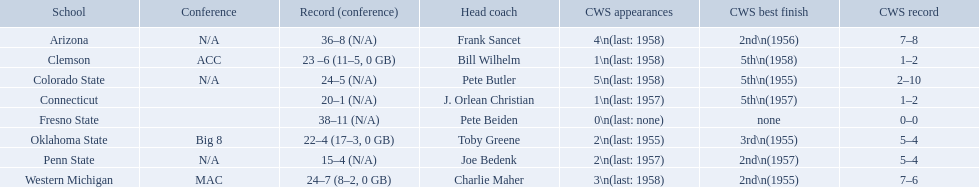Could you help me parse every detail presented in this table? {'header': ['School', 'Conference', 'Record (conference)', 'Head coach', 'CWS appearances', 'CWS best finish', 'CWS record'], 'rows': [['Arizona', 'N/A', '36–8 (N/A)', 'Frank Sancet', '4\\n(last: 1958)', '2nd\\n(1956)', '7–8'], ['Clemson', 'ACC', '23 –6 (11–5, 0 GB)', 'Bill Wilhelm', '1\\n(last: 1958)', '5th\\n(1958)', '1–2'], ['Colorado State', 'N/A', '24–5 (N/A)', 'Pete Butler', '5\\n(last: 1958)', '5th\\n(1955)', '2–10'], ['Connecticut', '', '20–1 (N/A)', 'J. Orlean Christian', '1\\n(last: 1957)', '5th\\n(1957)', '1–2'], ['Fresno State', '', '38–11 (N/A)', 'Pete Beiden', '0\\n(last: none)', 'none', '0–0'], ['Oklahoma State', 'Big 8', '22–4 (17–3, 0 GB)', 'Toby Greene', '2\\n(last: 1955)', '3rd\\n(1955)', '5–4'], ['Penn State', 'N/A', '15–4 (N/A)', 'Joe Bedenk', '2\\n(last: 1957)', '2nd\\n(1957)', '5–4'], ['Western Michigan', 'MAC', '24–7 (8–2, 0 GB)', 'Charlie Maher', '3\\n(last: 1958)', '2nd\\n(1955)', '7–6']]} What were scores for each school in the 1959 ncaa tournament? 36–8 (N/A), 23 –6 (11–5, 0 GB), 24–5 (N/A), 20–1 (N/A), 38–11 (N/A), 22–4 (17–3, 0 GB), 15–4 (N/A), 24–7 (8–2, 0 GB). What score did not have at least 16 wins? 15–4 (N/A). What team earned this score? Penn State. What was the least amount of wins recorded by the losingest team? 15–4 (N/A). Which team held this record? Penn State. What are all of the schools? Arizona, Clemson, Colorado State, Connecticut, Fresno State, Oklahoma State, Penn State, Western Michigan. Which team had fewer than 20 wins? Penn State. What are the listed schools? Arizona, Clemson, Colorado State, Connecticut, Fresno State, Oklahoma State, Penn State, Western Michigan. Which are clemson and western michigan? Clemson, Western Michigan. What are their corresponding numbers of cws appearances? 1\n(last: 1958), 3\n(last: 1958). Which value is larger? 3\n(last: 1958). To which school does that value belong to? Western Michigan. What was the minimum number of victories registered by the most defeated team? 15–4 (N/A). Which team held this record? Penn State. What are all the names of academic institutions? Arizona, Clemson, Colorado State, Connecticut, Fresno State, Oklahoma State, Penn State, Western Michigan. What is their respective record? 36–8 (N/A), 23 –6 (11–5, 0 GB), 24–5 (N/A), 20–1 (N/A), 38–11 (N/A), 22–4 (17–3, 0 GB), 15–4 (N/A), 24–7 (8–2, 0 GB). Which school had the minimum number of wins? Penn State. What were the tallies for each school in the 1959 ncaa tournament? 36–8 (N/A), 23 –6 (11–5, 0 GB), 24–5 (N/A), 20–1 (N/A), 38–11 (N/A), 22–4 (17–3, 0 GB), 15–4 (N/A), 24–7 (8–2, 0 GB). Which score lacked at least 16 wins? 15–4 (N/A). What team secured this score? Penn State. What are the mentioned educational institutions? Arizona, Clemson, Colorado State, Connecticut, Fresno State, Oklahoma State, Penn State, Western Michigan. Which include clemson and western michigan? Clemson, Western Michigan. What are their respective numbers of cws participations? 1\n(last: 1958), 3\n(last: 1958). Which amount is greater? 3\n(last: 1958). To which institution does that number pertain? Western Michigan. What are every one of the educational institutions? Arizona, Clemson, Colorado State, Connecticut, Fresno State, Oklahoma State, Penn State, Western Michigan. Which squad had less than 20 victories? Penn State. In the conference, what are the teams? Arizona, Clemson, Colorado State, Connecticut, Fresno State, Oklahoma State, Penn State, Western Michigan. Which teams have achieved more than 16 wins? Arizona, Clemson, Colorado State, Connecticut, Fresno State, Oklahoma State, Western Michigan. Which teams have not reached 16 wins? Penn State. What were the individual scores for every school in the 1959 ncaa tournament? 36–8 (N/A), 23 –6 (11–5, 0 GB), 24–5 (N/A), 20–1 (N/A), 38–11 (N/A), 22–4 (17–3, 0 GB), 15–4 (N/A), 24–7 (8–2, 0 GB). Which score didn't have a minimum of 16 victories? 15–4 (N/A). Which team achieved this score? Penn State. What was the lowest number of victories achieved by the team with the most losses? 15–4 (N/A). Which team holds this record? Penn State. Can you provide a list of all the schools? Arizona, Clemson, Colorado State, Connecticut, Fresno State, Oklahoma State, Penn State, Western Michigan. Which team acquired under 20 wins? Penn State. How many times has clemson participated in the college world series? 1\n(last: 1958). How many times has western michigan participated in the college world series? 3\n(last: 1958). Which of these two schools has a greater number of college world series participations? Western Michigan. 